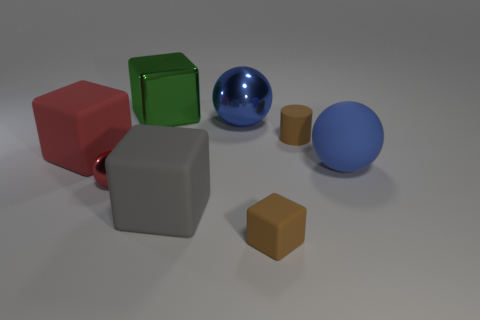Add 2 small purple metal cylinders. How many objects exist? 10 Subtract all cylinders. How many objects are left? 7 Subtract 0 purple cubes. How many objects are left? 8 Subtract all brown matte blocks. Subtract all large red objects. How many objects are left? 6 Add 3 small brown matte cylinders. How many small brown matte cylinders are left? 4 Add 4 rubber blocks. How many rubber blocks exist? 7 